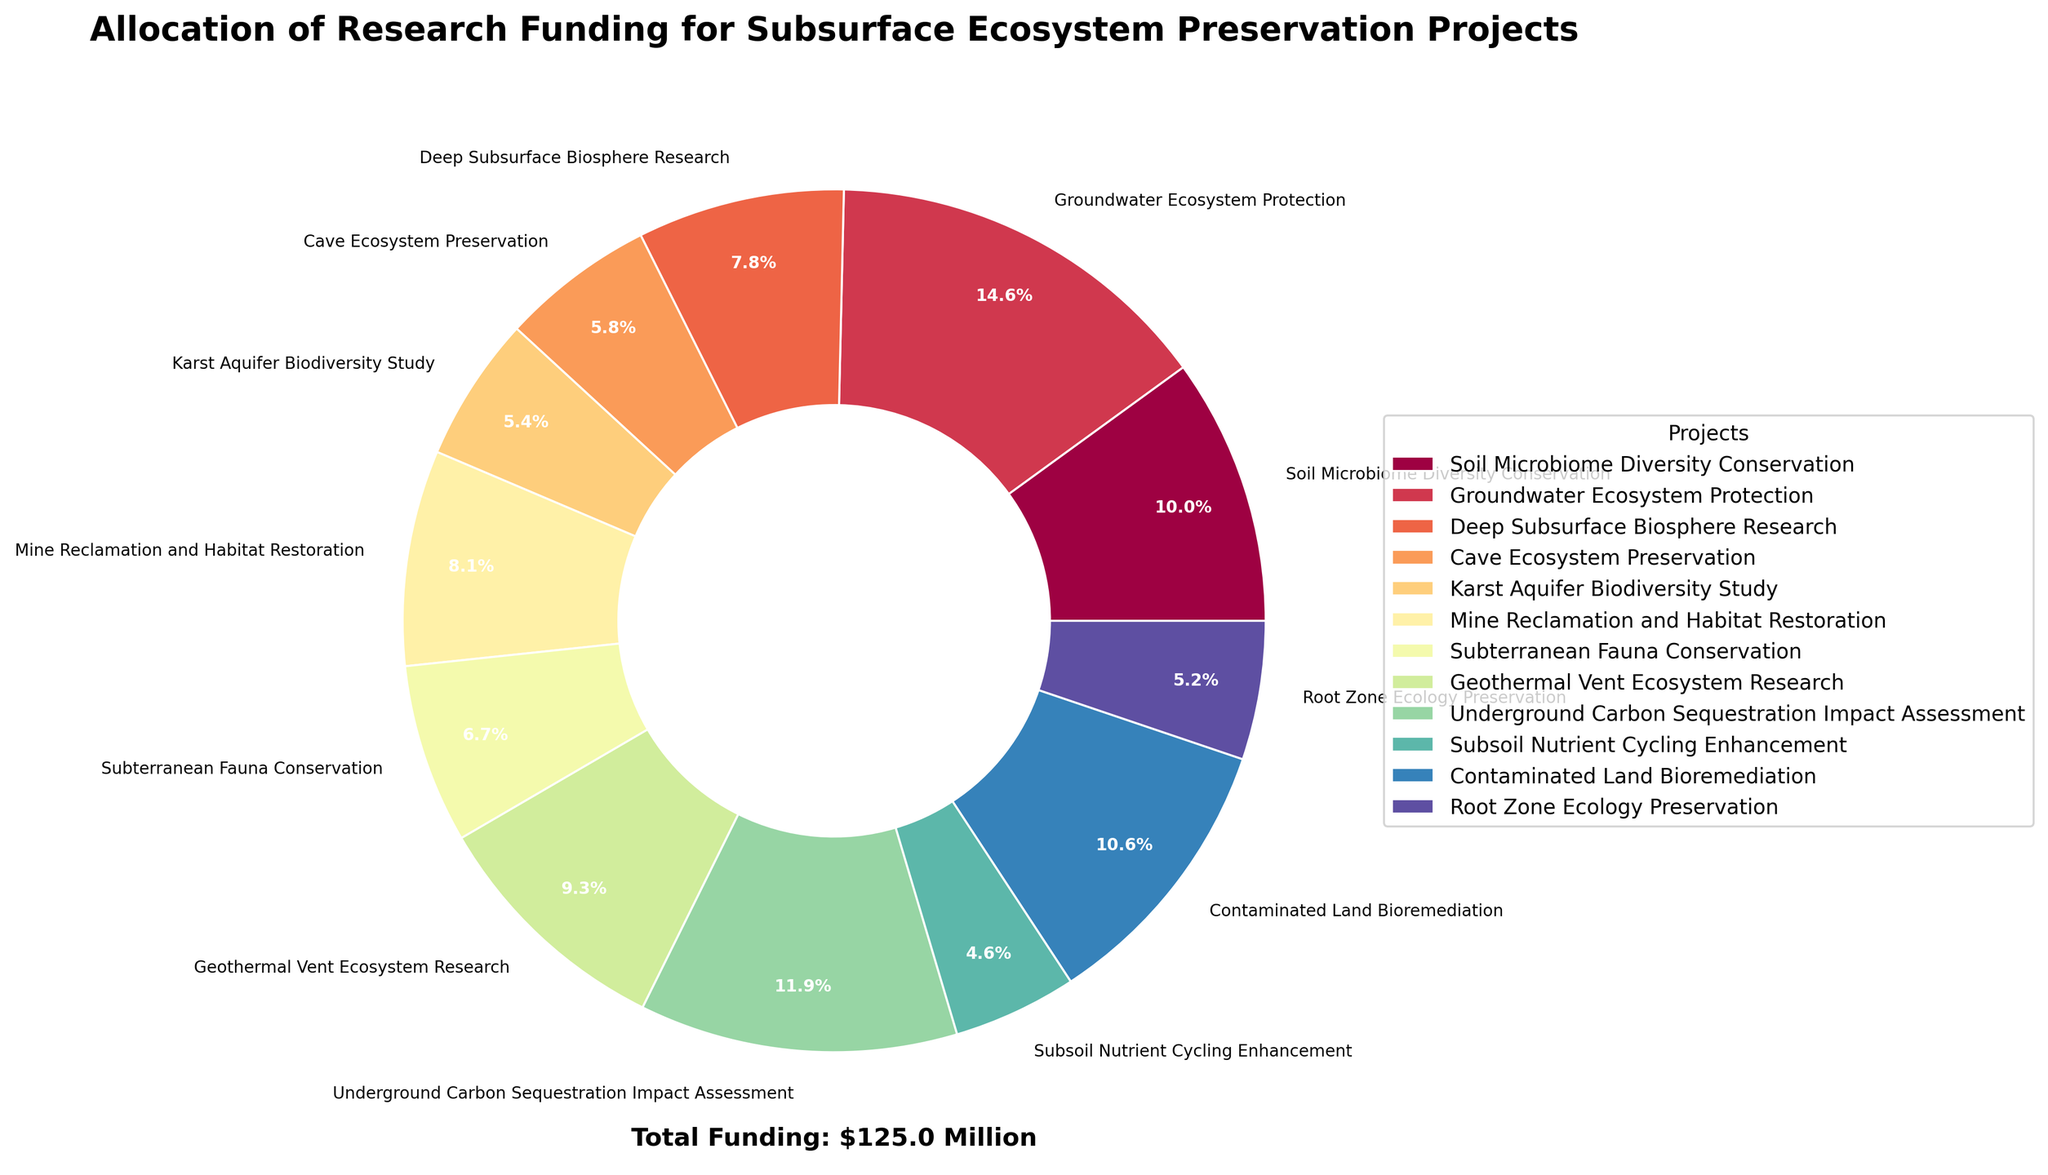Which project received the highest funding? The segment with the largest area in the pie chart represents the project that received the highest funding. Based on the chart, "Groundwater Ecosystem Protection" has the largest segment.
Answer: Groundwater Ecosystem Protection How much more funding did the "Underground Carbon Sequestration Impact Assessment" project receive compared to the "Karst Aquifer Biodiversity Study" project? Subtract the funding of the "Karst Aquifer Biodiversity Study" from the funding of the "Underground Carbon Sequestration Impact Assessment". Calculations: $14.9 million - $6.8 million = $8.1 million.
Answer: $8.1 million What is the total funding allocated for "Cave Ecosystem Preservation" and "Mine Reclamation and Habitat Restoration"? Add the funding for "Cave Ecosystem Preservation" and "Mine Reclamation and Habitat Restoration" projects. Calculations: $7.2 million + $10.1 million = $17.3 million.
Answer: $17.3 million Which three projects have the smallest funding amounts? Look for the smallest segments in the pie chart and identify the corresponding projects. The projects with the smallest segments are "Subsoil Nutrient Cycling Enhancement", "Karst Aquifer Biodiversity Study", and "Root Zone Ecology Preservation".
Answer: Subsoil Nutrient Cycling Enhancement, Karst Aquifer Biodiversity Study, Root Zone Ecology Preservation What is the combined percentage of total funding for "Geothermal Vent Ecosystem Research" and "Contaminated Land Bioremediation"? Identify the percentage values for both projects from the pie chart and add them. Calculations: 10.2% (for Geothermal Vent Ecosystem Research) + 11.6% (for Contaminated Land Bioremediation) = 21.8%.
Answer: 21.8% Which project has a funding amount closest to $10 million? Identify the segment whose funding most closely approximates $10 million. "Mine Reclamation and Habitat Restoration" has funding amount closest to $10 million ($10.1 million).
Answer: Mine Reclamation and Habitat Restoration How many projects have a funding amount greater than $10 million? Count the number of segments for which the funding amount exceeds $10 million. There are 5 projects with funding amounts greater than $10 million.
Answer: 5 What is the average funding across all projects? Sum up all the project funding amounts and then divide by the number of projects (12). Calculations: (12.5 + 18.3 + 9.7 + 7.2 + 6.8 + 10.1 + 8.4 + 11.6 + 14.9 + 5.8 + 13.2 + 6.5) / 12 = 10.475 million.
Answer: $10.5 million What is the funding difference between the highest-funded project and the lowest-funded project? Identify the highest and lowest funding amounts from the chart. Then subtract the smallest funding amount from the largest one. Calculations: $18.3 million (highest) - $5.8 million (lowest) = $12.5 million.
Answer: $12.5 million Which color represents the "Deep Subsurface Biosphere Research" project? Look at the color legend and match it with the "Deep Subsurface Biosphere Research" project. The color can be identified visually from the chart.
Answer: Yellow/Orange (Please check pie chart for exact shade) 